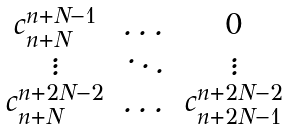<formula> <loc_0><loc_0><loc_500><loc_500>\begin{matrix} c ^ { n + N - 1 } _ { n + N } & \dots & 0 \\ \vdots & \ddots & \vdots \\ c ^ { n + 2 N - 2 } _ { n + N } & \dots & c ^ { n + 2 N - 2 } _ { n + 2 N - 1 } \end{matrix}</formula> 